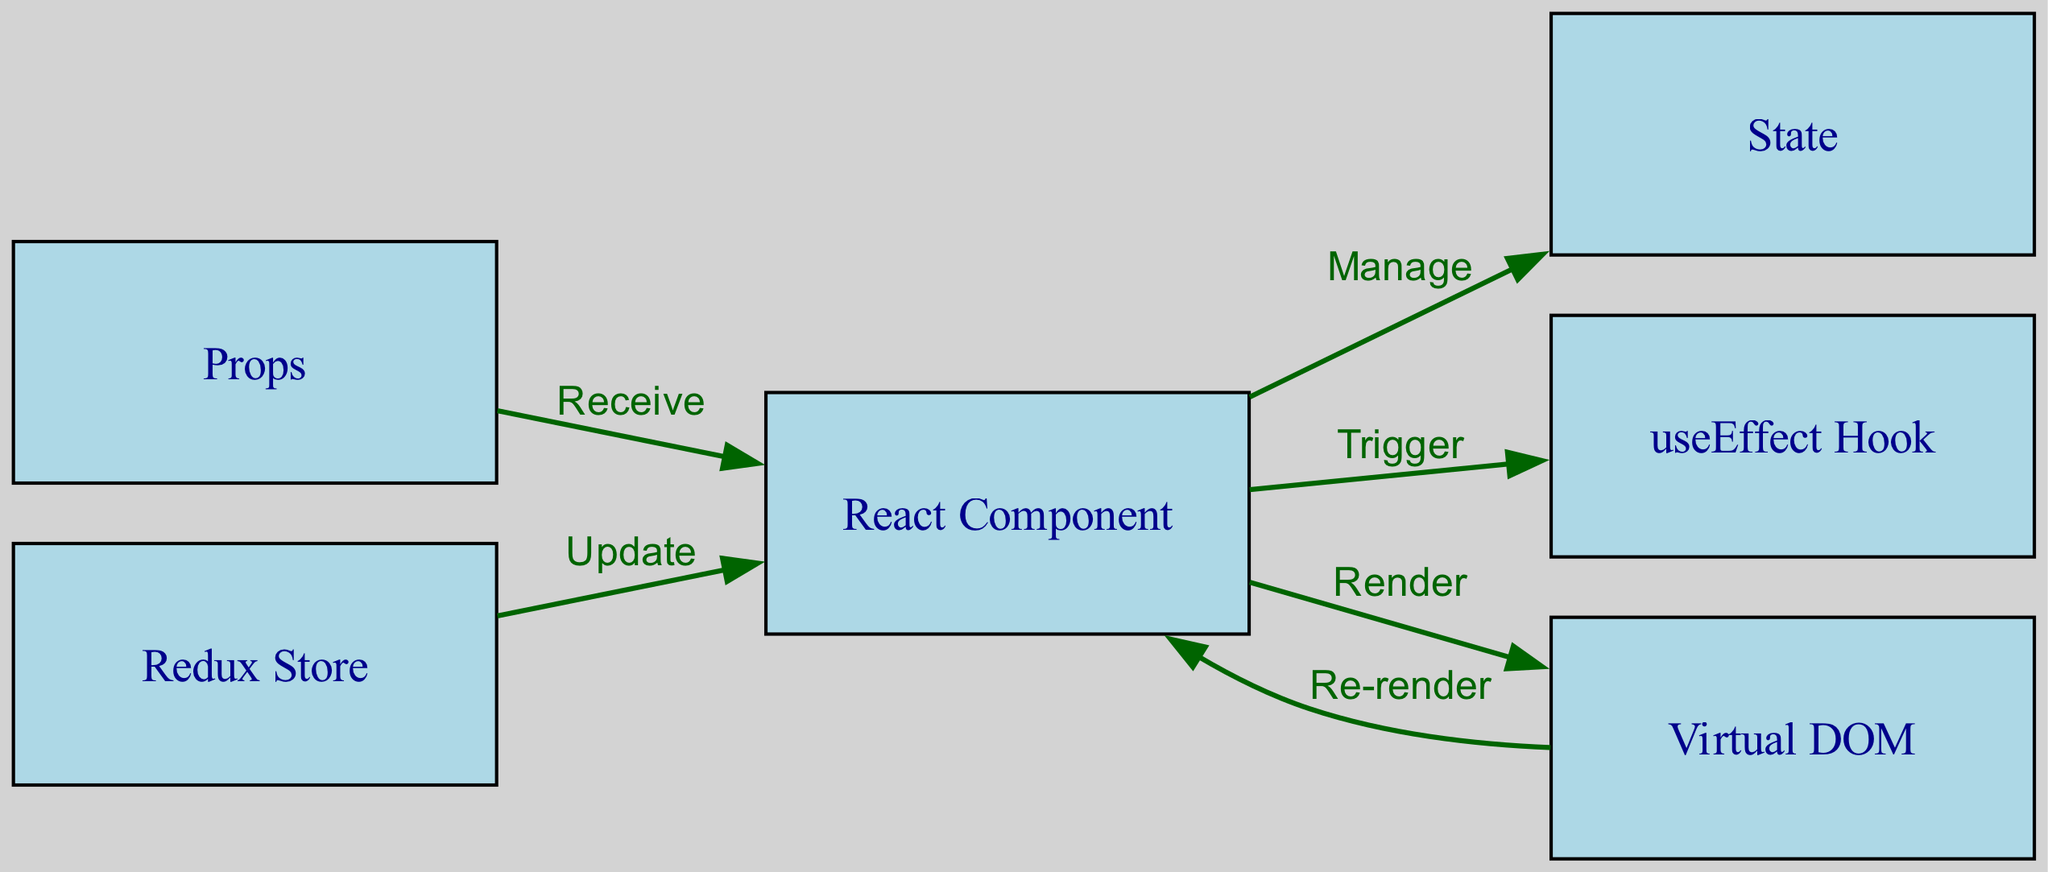What is the number of nodes in the diagram? The diagram contains several nodes representing different components of the React lifecycle and state management. Counting these nodes gives us the total. There are six nodes in total: React Component, Props, State, Redux Store, useEffect Hook, and Virtual DOM.
Answer: 6 Which node receives Props? In the diagram, there is a clear directed edge from Props to React Component labeled 'Receive'. This indicates that the React Component is the node that receives Props.
Answer: React Component What does the React Component manage? The diagram shows an edge labeled 'Manage' going from React Component to State. This indicates that the React Component's responsibility includes managing State.
Answer: State Which node is updated by the Redux Store? There is an edge from Redux Store to React Component labeled 'Update', showing that the React Component is the one receiving updates from the Redux Store.
Answer: React Component How many relationships are there in total? Relationships, or edges, in the diagram indicate connections between nodes. Counting the edges shows the total number of relationships. There are five edges illustrated.
Answer: 5 What triggers the useEffect Hook in the diagram? The diagram shows that the React Component is triggering the useEffect Hook, as indicated by the edge labeled 'Trigger' pointing from React Component to useEffect Hook.
Answer: React Component What happens after the Virtual DOM is rendered? According to the diagram, after the Virtual DOM is rendered, there is an edge labeled 'Re-render' going back to the React Component. This indicates that the React Component is re-rendered as a result.
Answer: React Component What is the role of the useEffect Hook in the diagram? The useEffect Hook is triggered by the React Component as a part of managing side effects. This relationship is shown by the directed edge labeled 'Trigger'. Therefore, its role is to manage side effects triggered by the React Component.
Answer: Manage side effects Which component manages state apart from the React Component? In this diagram, the only node that explicitly manages State is the React Component. Although the Redux Store updates React Component, it is not shown as managing State directly. Therefore, the answer is that no other component besides the React Component manages State directly in this context.
Answer: None 